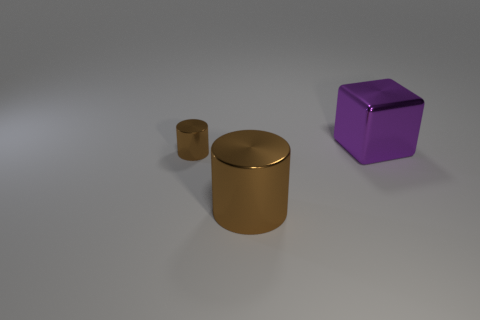Add 3 big purple metallic cubes. How many objects exist? 6 Subtract all cylinders. How many objects are left? 1 Subtract all brown metal balls. Subtract all big metallic objects. How many objects are left? 1 Add 1 large shiny cubes. How many large shiny cubes are left? 2 Add 1 cylinders. How many cylinders exist? 3 Subtract 0 cyan cylinders. How many objects are left? 3 